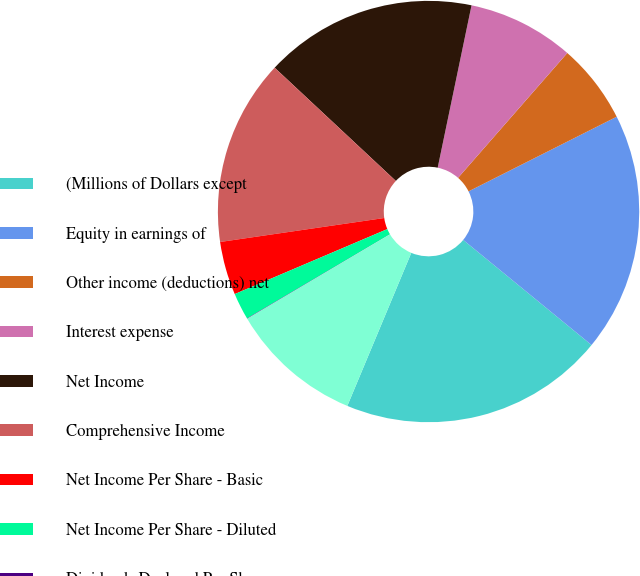Convert chart. <chart><loc_0><loc_0><loc_500><loc_500><pie_chart><fcel>(Millions of Dollars except<fcel>Equity in earnings of<fcel>Other income (deductions) net<fcel>Interest expense<fcel>Net Income<fcel>Comprehensive Income<fcel>Net Income Per Share - Basic<fcel>Net Income Per Share - Diluted<fcel>Dividends Declared Per Share<fcel>Average Number Of Shares<nl><fcel>20.38%<fcel>18.35%<fcel>6.13%<fcel>8.17%<fcel>16.31%<fcel>14.27%<fcel>4.1%<fcel>2.06%<fcel>0.03%<fcel>10.2%<nl></chart> 